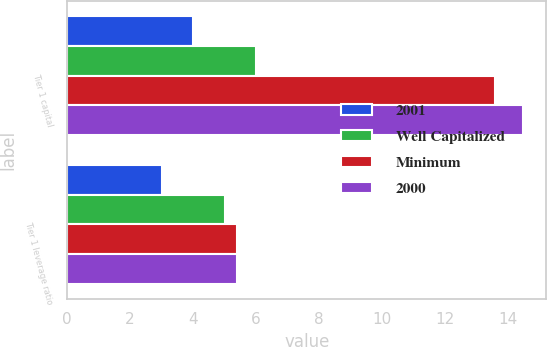<chart> <loc_0><loc_0><loc_500><loc_500><stacked_bar_chart><ecel><fcel>Tier 1 capital<fcel>Tier 1 leverage ratio<nl><fcel>2001<fcel>4<fcel>3<nl><fcel>Well Capitalized<fcel>6<fcel>5<nl><fcel>Minimum<fcel>13.6<fcel>5.4<nl><fcel>2000<fcel>14.5<fcel>5.4<nl></chart> 